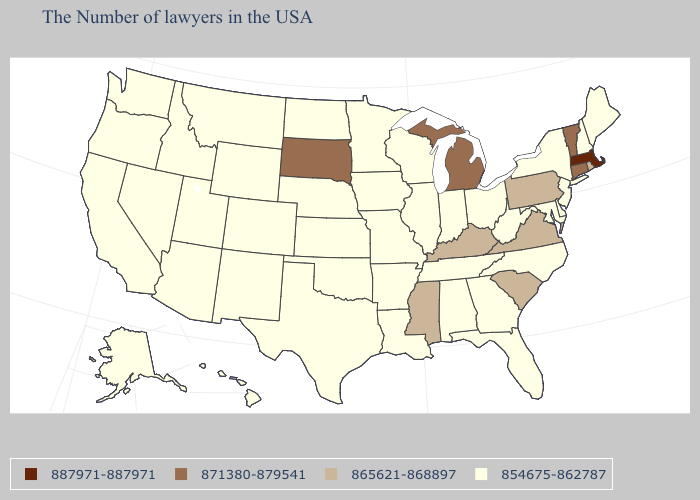Does Colorado have the lowest value in the USA?
Quick response, please. Yes. Name the states that have a value in the range 871380-879541?
Quick response, please. Vermont, Connecticut, Michigan, South Dakota. Among the states that border North Dakota , which have the lowest value?
Quick response, please. Minnesota, Montana. What is the value of Connecticut?
Answer briefly. 871380-879541. Among the states that border Arkansas , does Mississippi have the lowest value?
Give a very brief answer. No. Does Hawaii have the same value as South Dakota?
Be succinct. No. Does the map have missing data?
Answer briefly. No. What is the value of South Carolina?
Concise answer only. 865621-868897. Does Georgia have the highest value in the USA?
Give a very brief answer. No. What is the value of North Dakota?
Be succinct. 854675-862787. What is the highest value in the USA?
Concise answer only. 887971-887971. Which states have the lowest value in the South?
Answer briefly. Delaware, Maryland, North Carolina, West Virginia, Florida, Georgia, Alabama, Tennessee, Louisiana, Arkansas, Oklahoma, Texas. Name the states that have a value in the range 865621-868897?
Write a very short answer. Rhode Island, Pennsylvania, Virginia, South Carolina, Kentucky, Mississippi. Name the states that have a value in the range 865621-868897?
Keep it brief. Rhode Island, Pennsylvania, Virginia, South Carolina, Kentucky, Mississippi. What is the value of Tennessee?
Answer briefly. 854675-862787. 